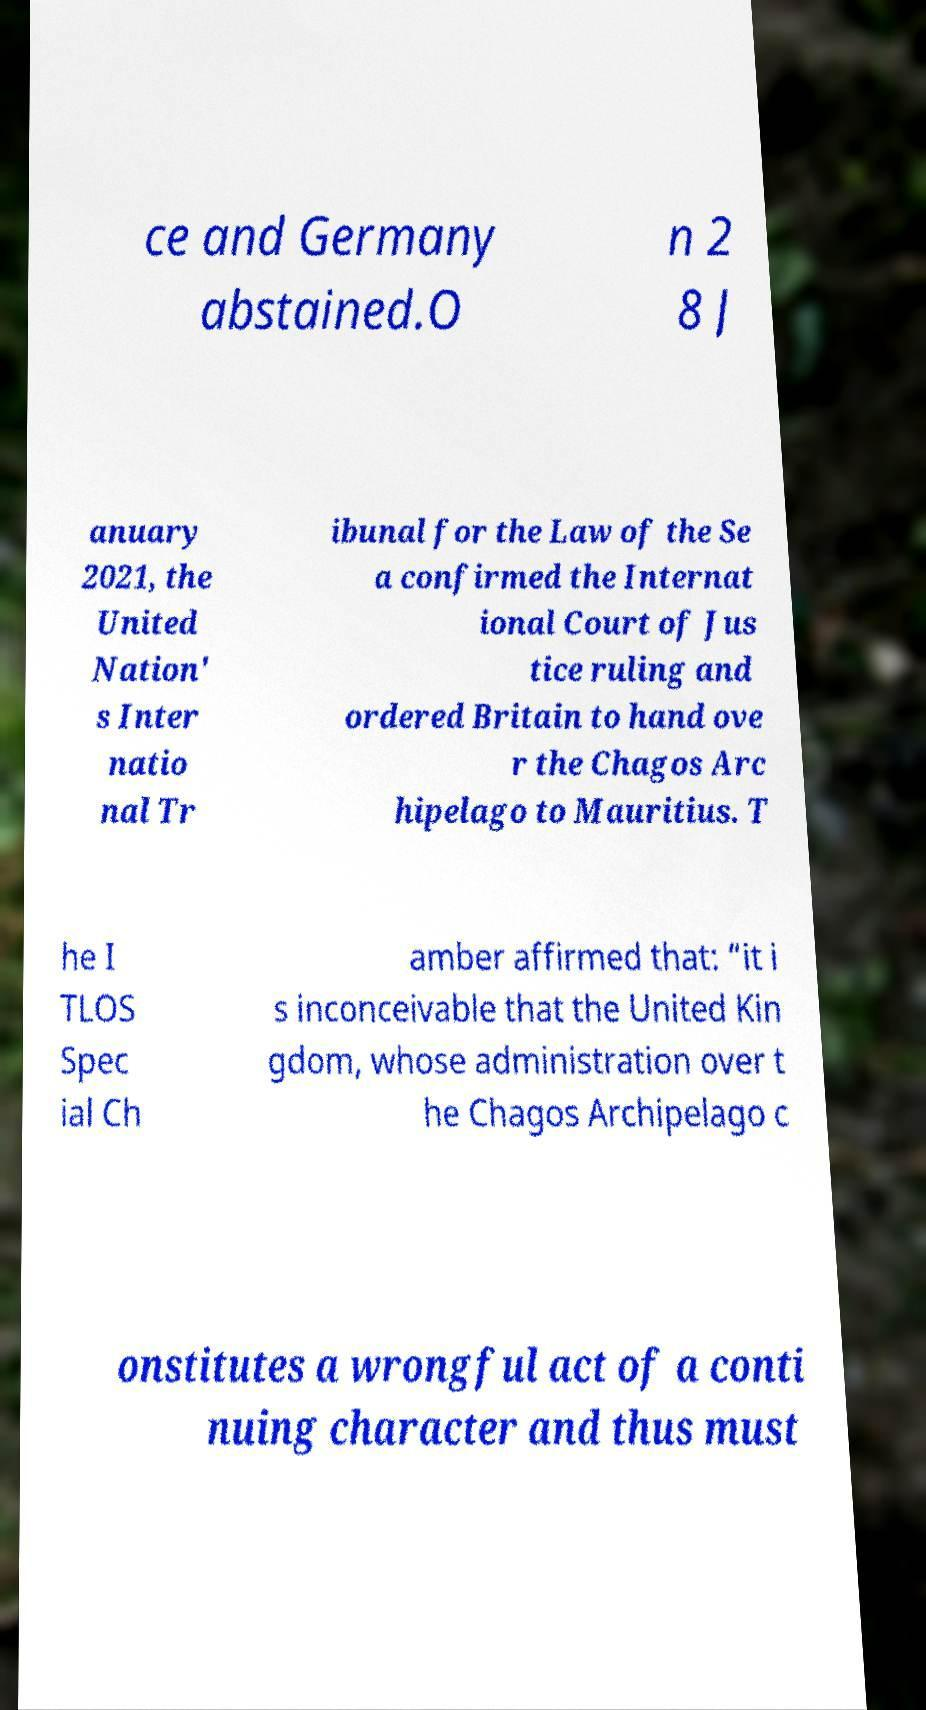Please read and relay the text visible in this image. What does it say? ce and Germany abstained.O n 2 8 J anuary 2021, the United Nation' s Inter natio nal Tr ibunal for the Law of the Se a confirmed the Internat ional Court of Jus tice ruling and ordered Britain to hand ove r the Chagos Arc hipelago to Mauritius. T he I TLOS Spec ial Ch amber affirmed that: “it i s inconceivable that the United Kin gdom, whose administration over t he Chagos Archipelago c onstitutes a wrongful act of a conti nuing character and thus must 